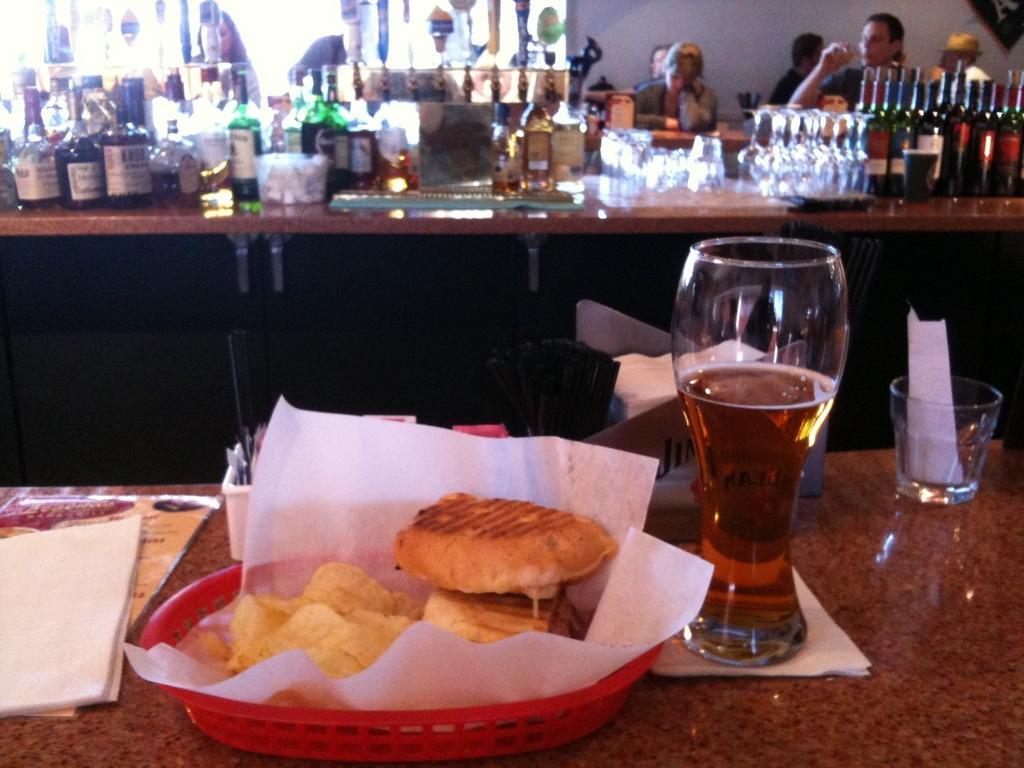Describe this image in one or two sentences. In the picture there are tables, there is a basket with the food items in it, there is a glass with the liquid, there are many bottles, glasses present, there are people sitting around the tables, behind them there is a wall. 